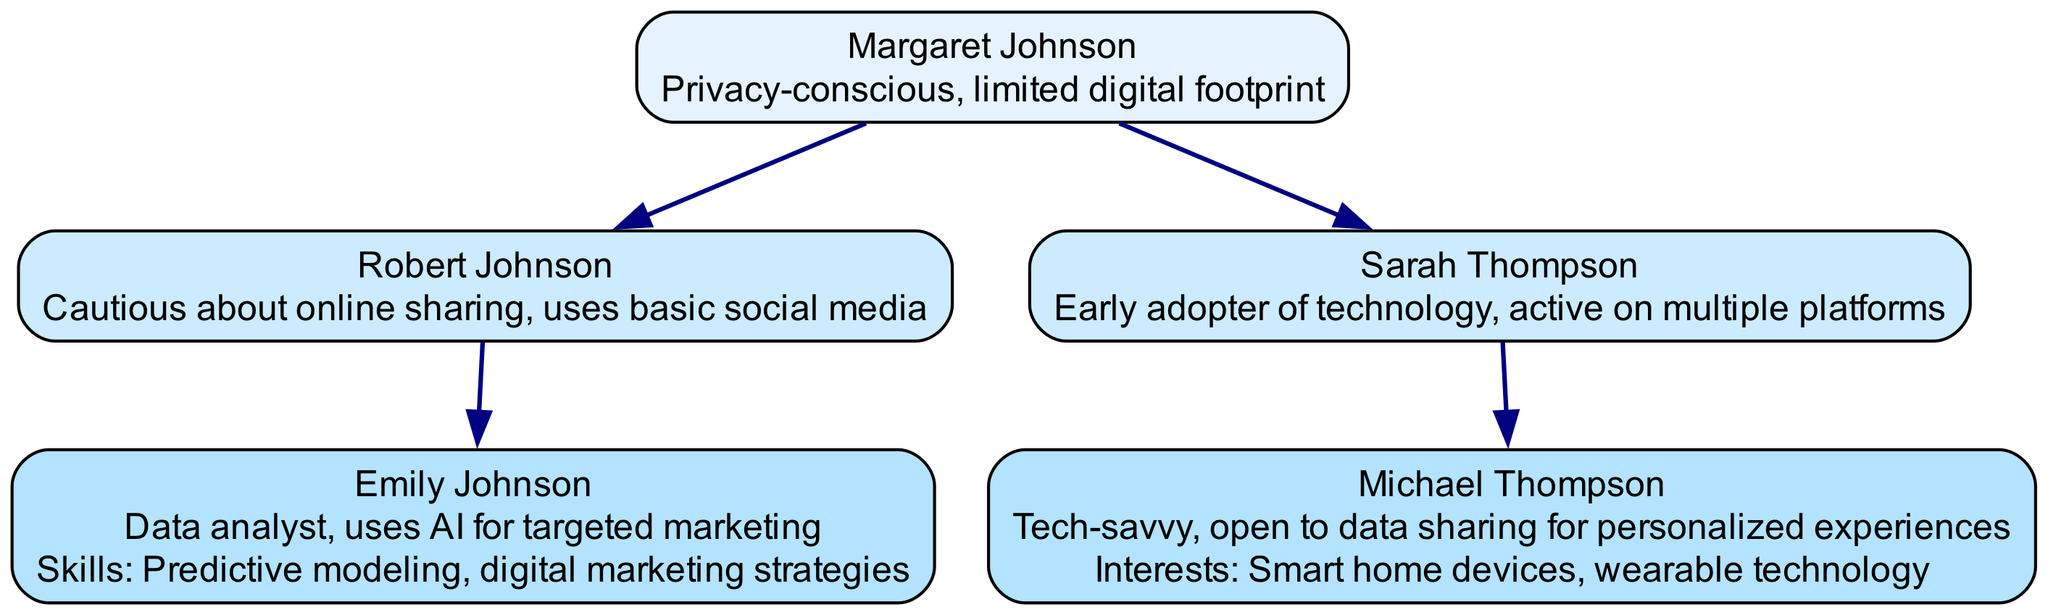What is the name of the first generation? The first generation is represented at the top of the family tree, which includes Margaret Johnson.
Answer: Margaret Johnson How many children does Robert Johnson have? By looking at the node for Robert Johnson, it shows that he has one child, Emily Johnson.
Answer: 1 Which generation has a data analyst? Upon examining the diagram, Emily Johnson, who is in Generation 3, is indicated as a data analyst.
Answer: Generation 3 What is the relationship between Sarah Thompson and Michael Thompson? Sarah Thompson is in Generation 2 and is Michael Thompson's parent, as he is listed as her child.
Answer: Parent-Child How many total individuals are represented in the family tree? Counting all the nodes, there are five individuals: Margaret Johnson, Robert Johnson, Sarah Thompson, Emily Johnson, and Michael Thompson.
Answer: 5 What trait does Michael Thompson possess? Looking at the node for Michael Thompson, it states that he is tech-savvy and open to data sharing for personalized experiences.
Answer: Tech-savvy Who are the children of Sarah Thompson? The node for Sarah Thompson indicates that she has one child, Michael Thompson.
Answer: Michael Thompson Which generation is characterized as privacy-conscious? The first generation, represented by Margaret Johnson, is described as privacy-conscious in her traits.
Answer: Generation 1 How many edges connect Generation 2 to Generation 3? Examining the connections, there are two edges: one from Robert Johnson to Emily Johnson, and another from Sarah Thompson to Michael Thompson.
Answer: 2 